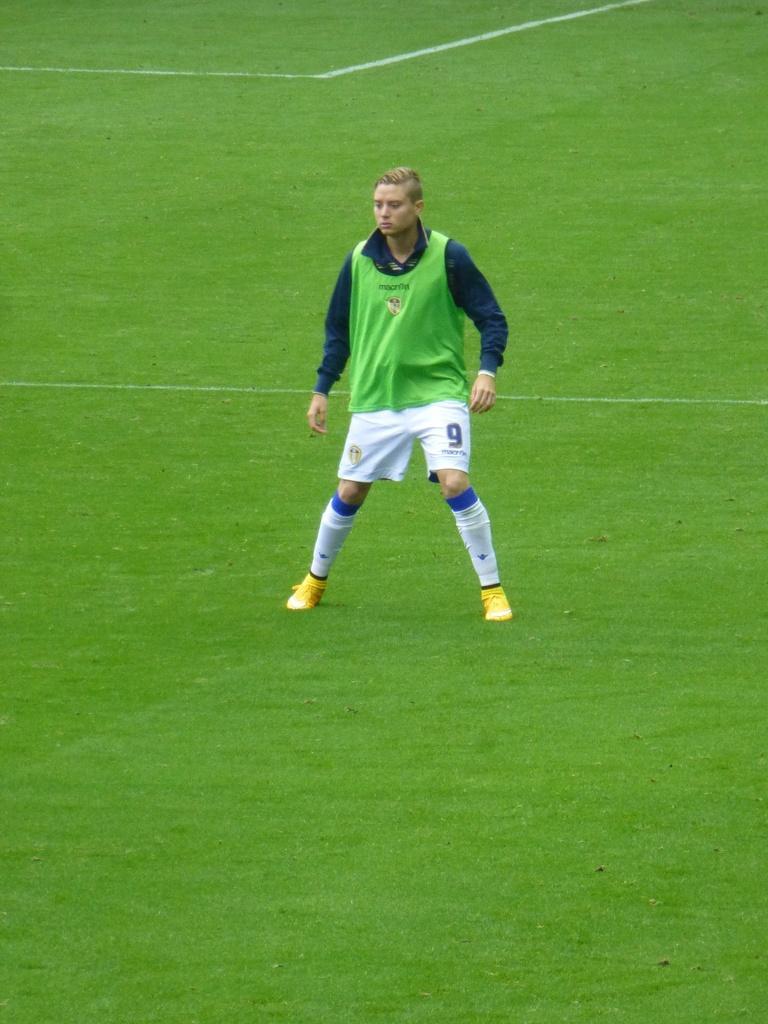Could you give a brief overview of what you see in this image? In the center of the image there is a person standing. At the bottom of the image there is grass. 